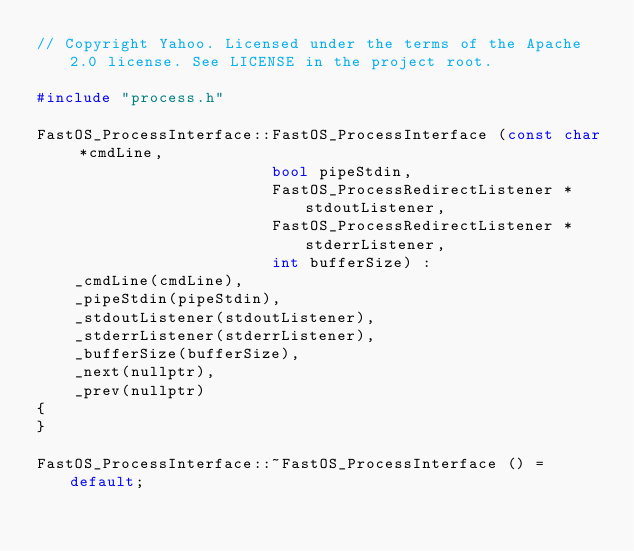Convert code to text. <code><loc_0><loc_0><loc_500><loc_500><_C++_>// Copyright Yahoo. Licensed under the terms of the Apache 2.0 license. See LICENSE in the project root.

#include "process.h"

FastOS_ProcessInterface::FastOS_ProcessInterface (const char *cmdLine,
                         bool pipeStdin,
                         FastOS_ProcessRedirectListener *stdoutListener,
                         FastOS_ProcessRedirectListener *stderrListener,
                         int bufferSize) :
    _cmdLine(cmdLine),
    _pipeStdin(pipeStdin),
    _stdoutListener(stdoutListener),
    _stderrListener(stderrListener),
    _bufferSize(bufferSize),
    _next(nullptr),
    _prev(nullptr)
{
}

FastOS_ProcessInterface::~FastOS_ProcessInterface () = default;
</code> 